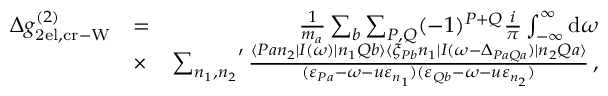Convert formula to latex. <formula><loc_0><loc_0><loc_500><loc_500>\begin{array} { r l r } { \Delta g _ { 2 e l , c r - W } ^ { ( 2 ) } } & { = } & { \frac { 1 } { m _ { a } } \sum _ { b } \sum _ { P , Q } ( - 1 ) ^ { P + Q } \frac { i } { \pi } \int _ { - \infty } ^ { \infty } d \omega } \\ & { \times } & { { \sum _ { n _ { 1 } , n _ { 2 } } } ^ { \prime } \, \frac { \langle P a n _ { 2 } | I ( \omega ) | n _ { 1 } Q b \rangle \langle \xi _ { P b } n _ { 1 } | I ( \omega - \Delta _ { P a Q a } ) | n _ { 2 } Q a \rangle } { ( \varepsilon _ { P a } - \omega - u \varepsilon _ { n _ { 1 } } ) ( \varepsilon _ { Q b } - \omega - u \varepsilon _ { n _ { 2 } } ) } \, , } \end{array}</formula> 